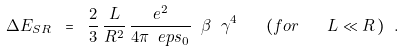<formula> <loc_0><loc_0><loc_500><loc_500>\Delta E _ { S R } \ = \ \frac { 2 } { 3 } \, \frac { L } { R ^ { 2 } } \, \frac { e ^ { 2 } } { 4 \pi \ e p s _ { 0 } } \ \beta \ \gamma ^ { 4 } \quad ( f o r \quad L \ll R \, ) \ .</formula> 